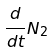<formula> <loc_0><loc_0><loc_500><loc_500>\frac { d } { d t } N _ { 2 }</formula> 